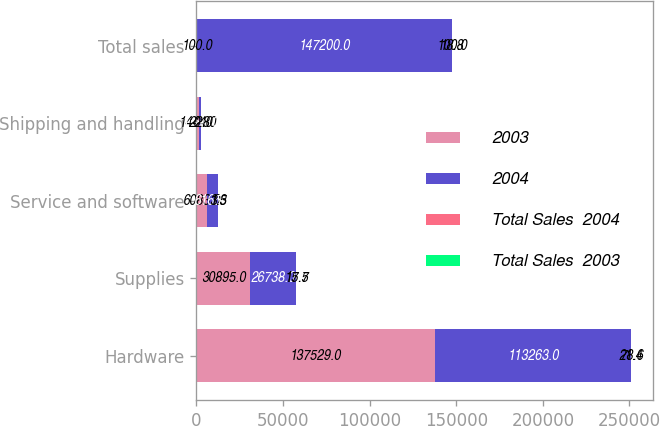Convert chart. <chart><loc_0><loc_0><loc_500><loc_500><stacked_bar_chart><ecel><fcel>Hardware<fcel>Supplies<fcel>Service and software<fcel>Shipping and handling<fcel>Total sales<nl><fcel>2003<fcel>137529<fcel>30895<fcel>6083<fcel>1444<fcel>100<nl><fcel>2004<fcel>113263<fcel>26738<fcel>6165<fcel>1184<fcel>147200<nl><fcel>Total Sales  2004<fcel>21.4<fcel>15.5<fcel>1.3<fcel>22<fcel>18.8<nl><fcel>Total Sales  2003<fcel>78.6<fcel>17.7<fcel>3.5<fcel>0.8<fcel>100<nl></chart> 